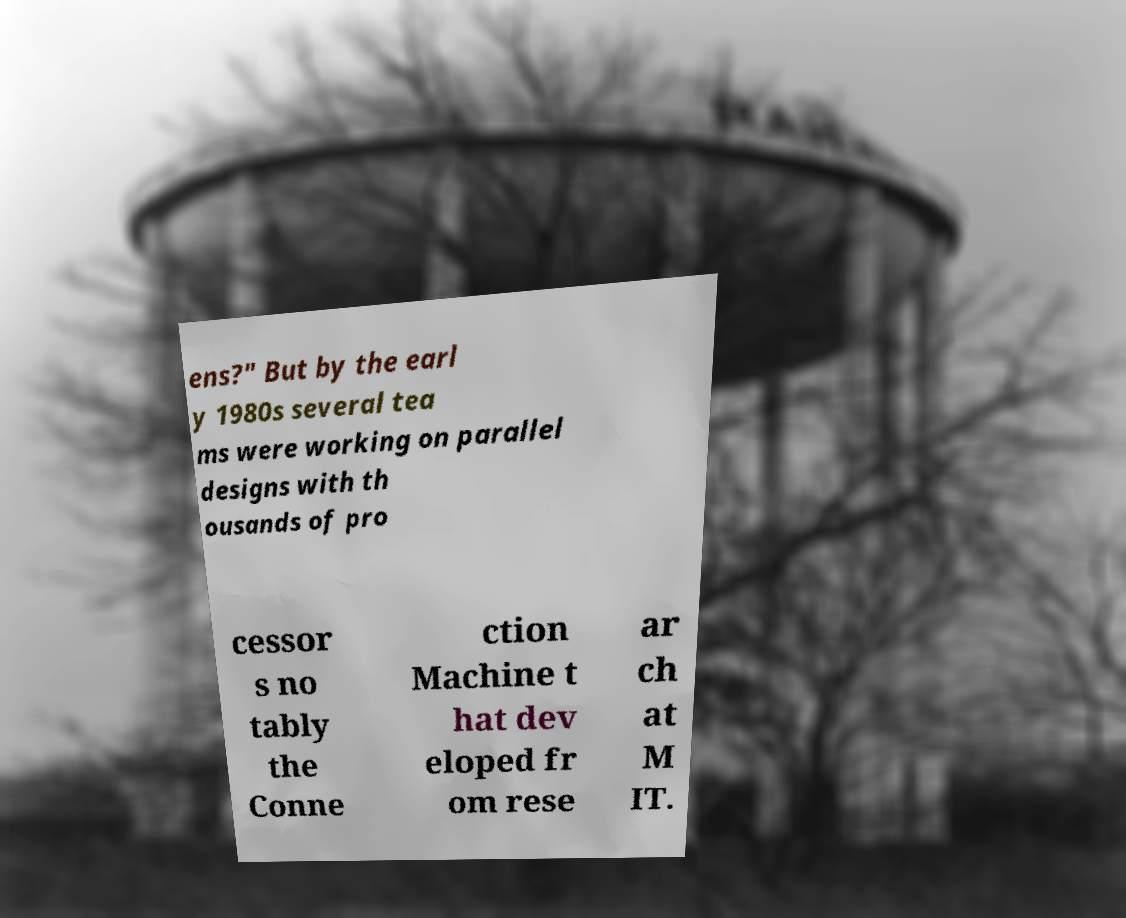Can you read and provide the text displayed in the image?This photo seems to have some interesting text. Can you extract and type it out for me? ens?" But by the earl y 1980s several tea ms were working on parallel designs with th ousands of pro cessor s no tably the Conne ction Machine t hat dev eloped fr om rese ar ch at M IT. 